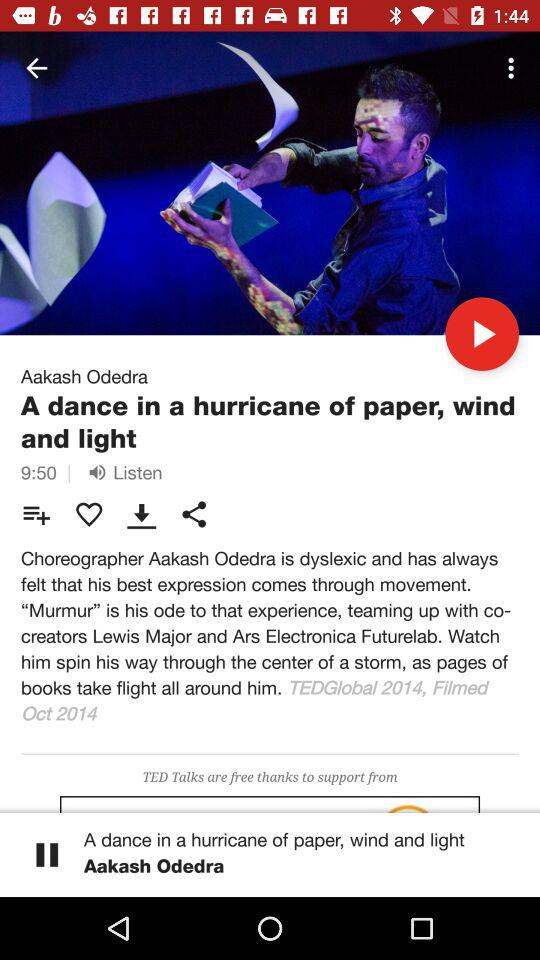What is the headline? The headline is "A dance in a hurricane of paper, wind and light". 